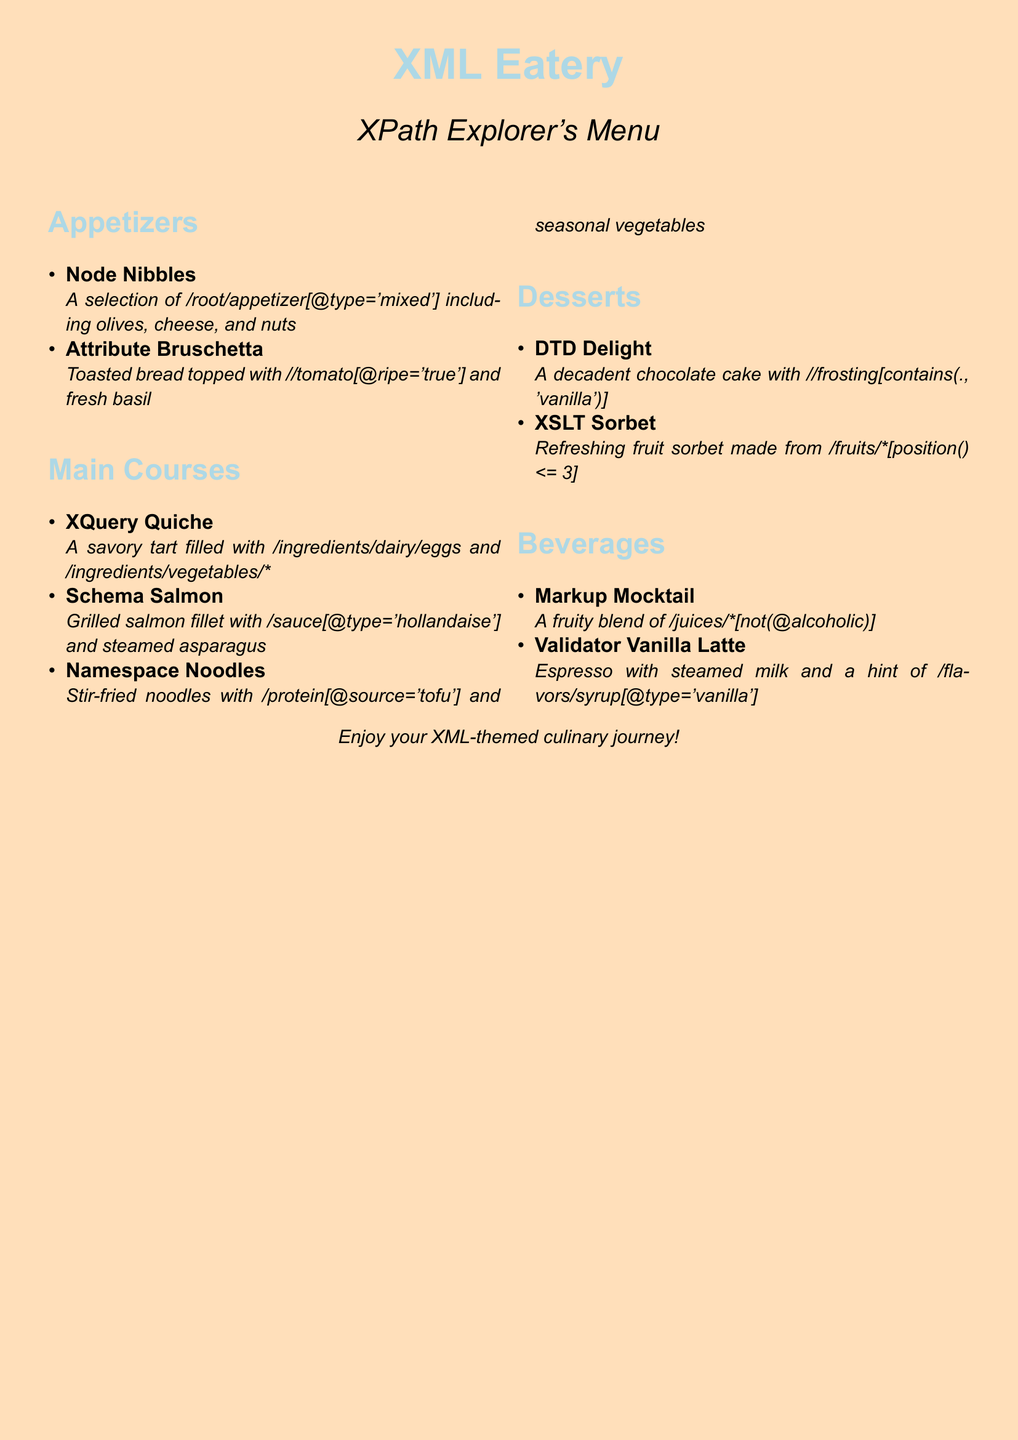What is the name of the restaurant? The name of the restaurant is prominently displayed at the top of the menu.
Answer: XML Eatery How many sections are in the menu? The menu has sections for Appetizers, Main Courses, Desserts, and Beverages, making a total of four sections.
Answer: 4 What type of dessert is listed that contains chocolate? The dessert that contains chocolate is mentioned under the Desserts section.
Answer: DTD Delight Which appetizer includes olives? The appetizer that includes olives is specified in the Appetizers section, alongside other items.
Answer: Node Nibbles What is the main ingredient of XQuery Quiche? The main ingredients of XQuery Quiche can be found under the description in the Main Courses section.
Answer: Eggs How is the Validator Vanilla Latte prepared? The preparation details of Validator Vanilla Latte can be found in the Beverages section.
Answer: Espresso with steamed milk Which dish features asparagus? The dish that features asparagus is indicated in the Main Courses section description.
Answer: Schema Salmon Which appetizer uses ripe tomatoes? The appetizer using ripe tomatoes is described directly in the Appetizers section.
Answer: Attribute Bruschetta What type of mocktail is offered? The type of mocktail offered is described in the Beverages section.
Answer: Markup Mocktail 